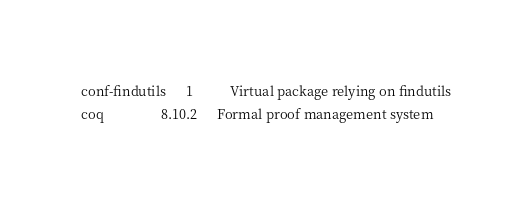<code> <loc_0><loc_0><loc_500><loc_500><_HTML_>conf-findutils      1           Virtual package relying on findutils
coq                 8.10.2      Formal proof management system</code> 